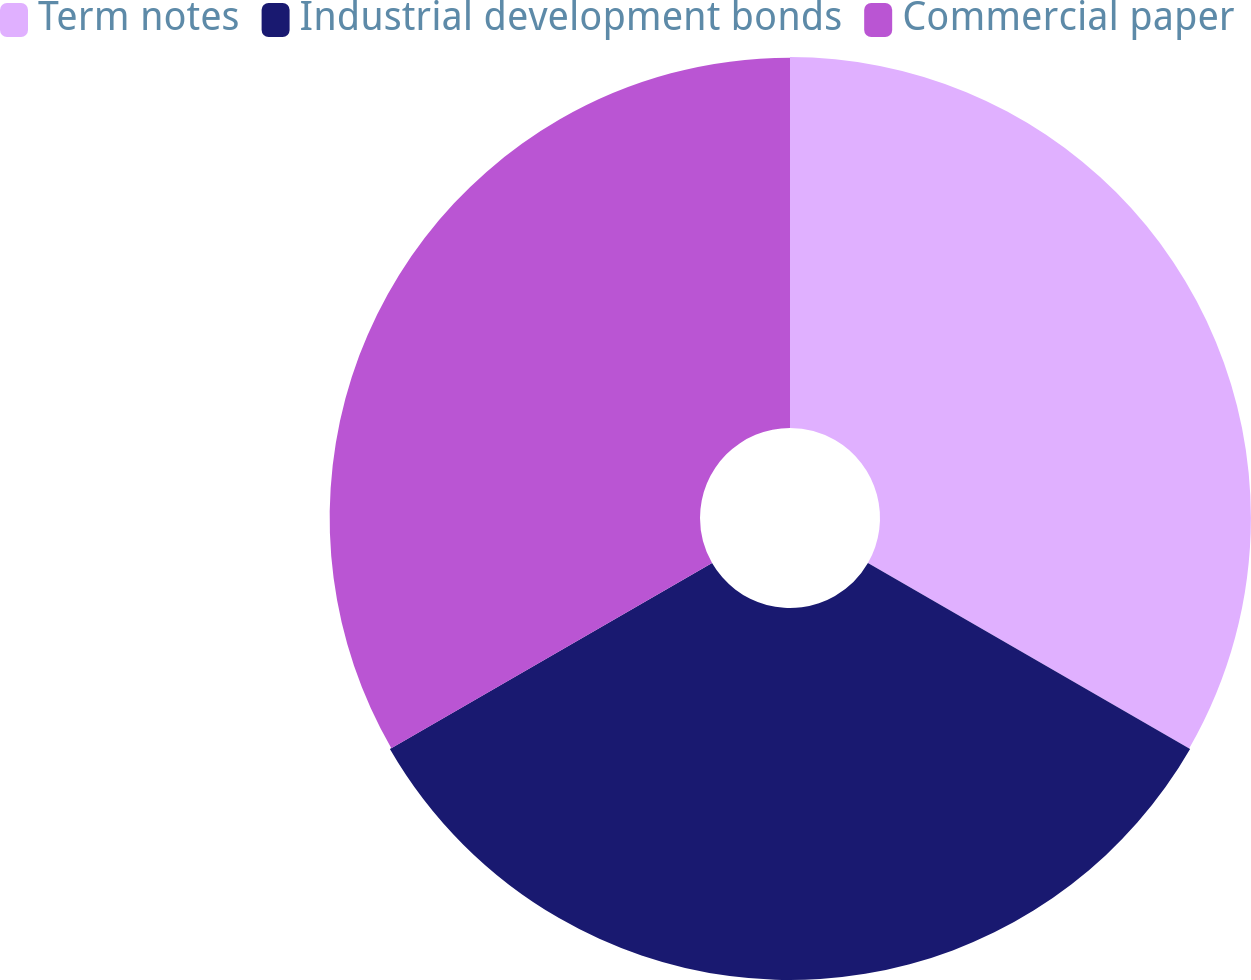Convert chart to OTSL. <chart><loc_0><loc_0><loc_500><loc_500><pie_chart><fcel>Term notes<fcel>Industrial development bonds<fcel>Commercial paper<nl><fcel>33.32%<fcel>33.42%<fcel>33.27%<nl></chart> 